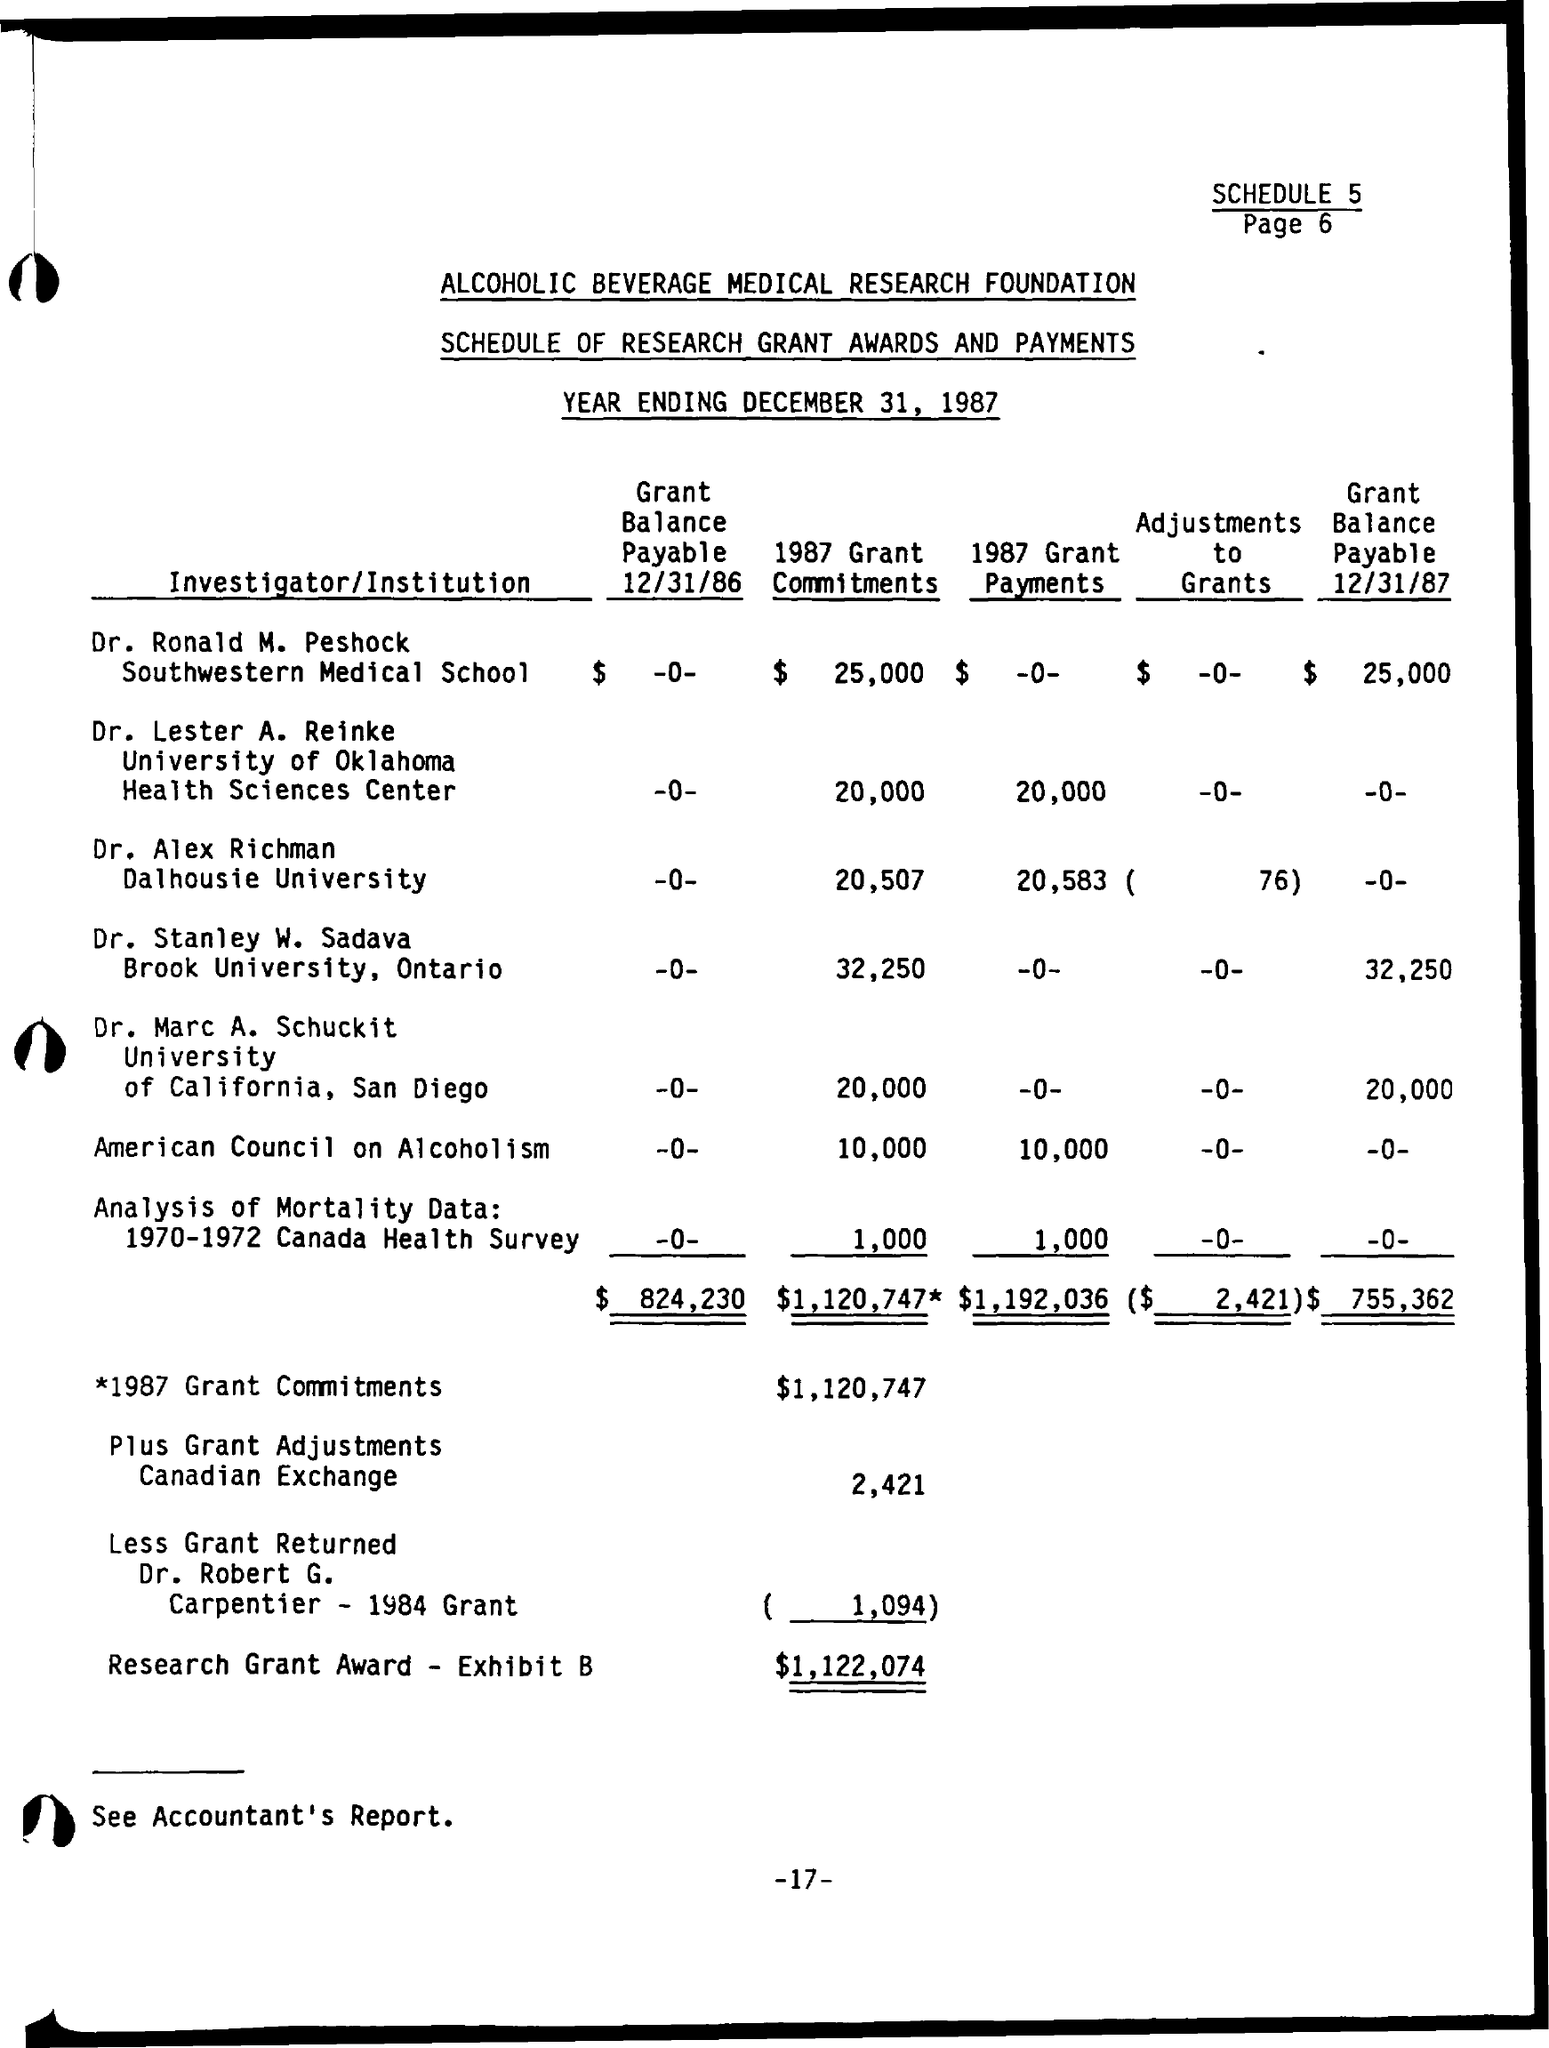Highlight a few significant elements in this photo. The total amount of adjustments to grants, as displayed on the given page, is $2,421. Dr. Alex Richman is affiliated with Dalhousie University. The year ending date mentioned on the given page is December 31, 1987. The amount of 1987 grant commitments mentioned on the given page is $1,120,747. The total grant balance payable as shown on the page on 12/31/86 is $824,230. 